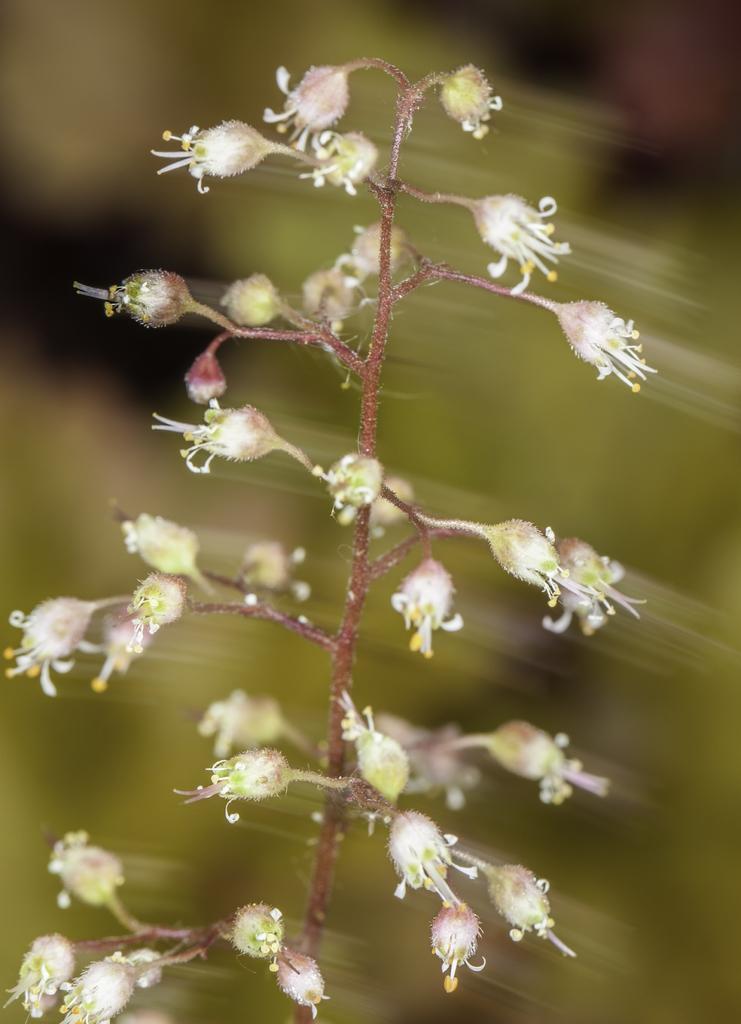In one or two sentences, can you explain what this image depicts? In the picture I can see the flowering plant in the middle of the image. I can see the buds of a plant. 